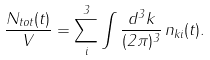Convert formula to latex. <formula><loc_0><loc_0><loc_500><loc_500>\frac { N _ { t o t } ( t ) } { V } = \sum ^ { 3 } _ { i } \int \frac { d ^ { 3 } k } { ( 2 \pi ) ^ { 3 } } \, n _ { k i } ( t ) .</formula> 